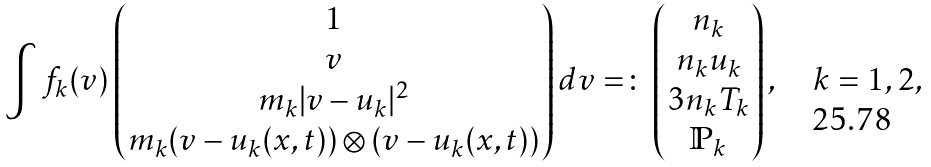<formula> <loc_0><loc_0><loc_500><loc_500>\int f _ { k } ( v ) \begin{pmatrix} 1 \\ v \\ m _ { k } | v - u _ { k } | ^ { 2 } \\ m _ { k } ( v - u _ { k } ( x , t ) ) \otimes ( v - u _ { k } ( x , t ) ) \end{pmatrix} d v = \colon \begin{pmatrix} n _ { k } \\ n _ { k } u _ { k } \\ 3 n _ { k } T _ { k } \\ \mathbb { P } _ { k } \end{pmatrix} , \quad k = 1 , 2 ,</formula> 